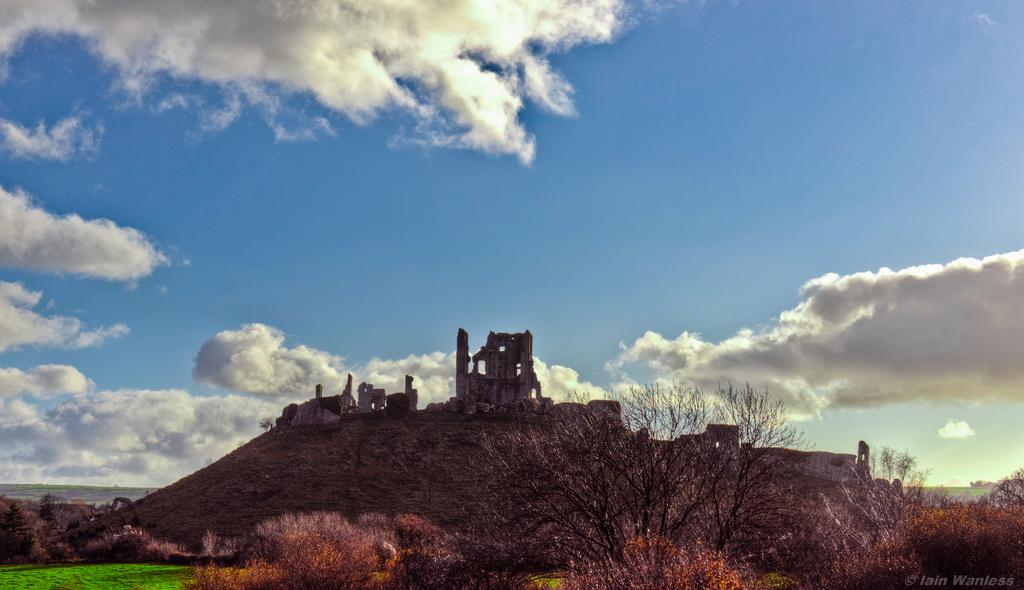What type of natural elements are present in the image? There are trees and plants in the image. What man-made structures can be seen on the hill in the image? There are ancient monuments on a hill in the middle of the image. What is visible in the sky in the image? There are clouds in the sky. What type of government is being discussed in the meeting depicted in the image? There is no meeting depicted in the image, so it is not possible to determine what type of government is being discussed. 